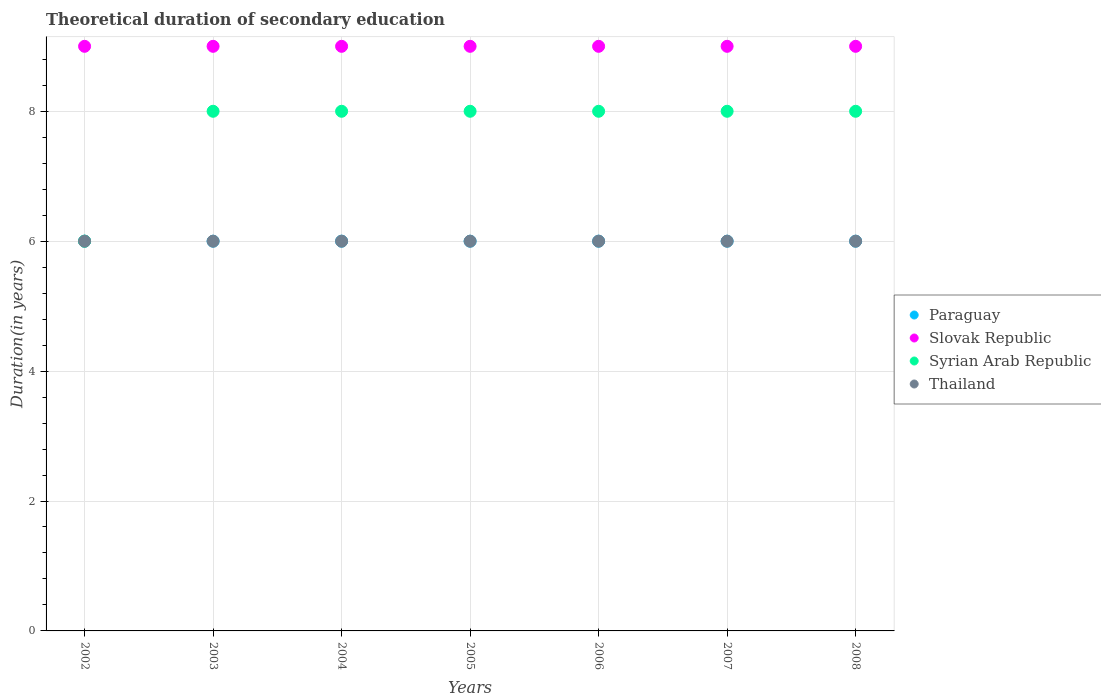Is the number of dotlines equal to the number of legend labels?
Offer a terse response. Yes. What is the total theoretical duration of secondary education in Thailand in 2008?
Offer a very short reply. 6. Across all years, what is the maximum total theoretical duration of secondary education in Syrian Arab Republic?
Ensure brevity in your answer.  8. What is the total total theoretical duration of secondary education in Slovak Republic in the graph?
Ensure brevity in your answer.  63. What is the difference between the total theoretical duration of secondary education in Thailand in 2003 and that in 2008?
Your answer should be compact. 0. What is the difference between the total theoretical duration of secondary education in Thailand in 2003 and the total theoretical duration of secondary education in Syrian Arab Republic in 2007?
Your answer should be very brief. -2. In the year 2005, what is the difference between the total theoretical duration of secondary education in Syrian Arab Republic and total theoretical duration of secondary education in Slovak Republic?
Give a very brief answer. -1. In how many years, is the total theoretical duration of secondary education in Paraguay greater than 5.6 years?
Ensure brevity in your answer.  7. Is the total theoretical duration of secondary education in Syrian Arab Republic in 2004 less than that in 2005?
Your response must be concise. No. Is the difference between the total theoretical duration of secondary education in Syrian Arab Republic in 2004 and 2005 greater than the difference between the total theoretical duration of secondary education in Slovak Republic in 2004 and 2005?
Your answer should be compact. No. What is the difference between the highest and the second highest total theoretical duration of secondary education in Syrian Arab Republic?
Your response must be concise. 0. What is the difference between the highest and the lowest total theoretical duration of secondary education in Syrian Arab Republic?
Keep it short and to the point. 2. Is the sum of the total theoretical duration of secondary education in Thailand in 2006 and 2007 greater than the maximum total theoretical duration of secondary education in Slovak Republic across all years?
Your response must be concise. Yes. Is it the case that in every year, the sum of the total theoretical duration of secondary education in Paraguay and total theoretical duration of secondary education in Slovak Republic  is greater than the sum of total theoretical duration of secondary education in Syrian Arab Republic and total theoretical duration of secondary education in Thailand?
Give a very brief answer. No. Is it the case that in every year, the sum of the total theoretical duration of secondary education in Slovak Republic and total theoretical duration of secondary education in Syrian Arab Republic  is greater than the total theoretical duration of secondary education in Thailand?
Keep it short and to the point. Yes. Is the total theoretical duration of secondary education in Syrian Arab Republic strictly less than the total theoretical duration of secondary education in Slovak Republic over the years?
Give a very brief answer. Yes. How many years are there in the graph?
Make the answer very short. 7. What is the difference between two consecutive major ticks on the Y-axis?
Offer a terse response. 2. Does the graph contain any zero values?
Ensure brevity in your answer.  No. Does the graph contain grids?
Keep it short and to the point. Yes. Where does the legend appear in the graph?
Ensure brevity in your answer.  Center right. How are the legend labels stacked?
Your response must be concise. Vertical. What is the title of the graph?
Your answer should be very brief. Theoretical duration of secondary education. Does "Congo (Republic)" appear as one of the legend labels in the graph?
Offer a very short reply. No. What is the label or title of the X-axis?
Your response must be concise. Years. What is the label or title of the Y-axis?
Make the answer very short. Duration(in years). What is the Duration(in years) in Slovak Republic in 2002?
Your answer should be compact. 9. What is the Duration(in years) in Syrian Arab Republic in 2002?
Provide a short and direct response. 6. What is the Duration(in years) in Thailand in 2002?
Give a very brief answer. 6. What is the Duration(in years) in Paraguay in 2003?
Provide a short and direct response. 6. What is the Duration(in years) of Slovak Republic in 2003?
Your answer should be compact. 9. What is the Duration(in years) in Paraguay in 2004?
Offer a terse response. 6. What is the Duration(in years) of Syrian Arab Republic in 2004?
Provide a succinct answer. 8. What is the Duration(in years) of Paraguay in 2005?
Make the answer very short. 6. What is the Duration(in years) in Paraguay in 2006?
Provide a succinct answer. 6. What is the Duration(in years) of Slovak Republic in 2006?
Your response must be concise. 9. What is the Duration(in years) in Syrian Arab Republic in 2006?
Your answer should be compact. 8. What is the Duration(in years) of Thailand in 2006?
Ensure brevity in your answer.  6. What is the Duration(in years) of Paraguay in 2007?
Your response must be concise. 6. What is the Duration(in years) in Slovak Republic in 2007?
Your answer should be very brief. 9. What is the Duration(in years) in Syrian Arab Republic in 2007?
Offer a very short reply. 8. What is the Duration(in years) in Paraguay in 2008?
Keep it short and to the point. 6. Across all years, what is the maximum Duration(in years) in Paraguay?
Ensure brevity in your answer.  6. Across all years, what is the maximum Duration(in years) in Slovak Republic?
Make the answer very short. 9. Across all years, what is the maximum Duration(in years) of Syrian Arab Republic?
Offer a very short reply. 8. Across all years, what is the minimum Duration(in years) in Paraguay?
Offer a terse response. 6. Across all years, what is the minimum Duration(in years) of Slovak Republic?
Offer a very short reply. 9. Across all years, what is the minimum Duration(in years) in Thailand?
Provide a short and direct response. 6. What is the total Duration(in years) in Paraguay in the graph?
Your answer should be very brief. 42. What is the difference between the Duration(in years) in Syrian Arab Republic in 2002 and that in 2003?
Ensure brevity in your answer.  -2. What is the difference between the Duration(in years) in Paraguay in 2002 and that in 2004?
Your answer should be compact. 0. What is the difference between the Duration(in years) in Syrian Arab Republic in 2002 and that in 2004?
Offer a terse response. -2. What is the difference between the Duration(in years) of Thailand in 2002 and that in 2004?
Offer a very short reply. 0. What is the difference between the Duration(in years) in Paraguay in 2002 and that in 2005?
Provide a short and direct response. 0. What is the difference between the Duration(in years) of Thailand in 2002 and that in 2005?
Give a very brief answer. 0. What is the difference between the Duration(in years) in Paraguay in 2002 and that in 2006?
Offer a terse response. 0. What is the difference between the Duration(in years) of Slovak Republic in 2002 and that in 2006?
Make the answer very short. 0. What is the difference between the Duration(in years) in Paraguay in 2002 and that in 2007?
Provide a short and direct response. 0. What is the difference between the Duration(in years) in Thailand in 2002 and that in 2007?
Your answer should be compact. 0. What is the difference between the Duration(in years) in Paraguay in 2002 and that in 2008?
Your answer should be very brief. 0. What is the difference between the Duration(in years) in Slovak Republic in 2002 and that in 2008?
Your answer should be very brief. 0. What is the difference between the Duration(in years) in Syrian Arab Republic in 2002 and that in 2008?
Give a very brief answer. -2. What is the difference between the Duration(in years) of Thailand in 2002 and that in 2008?
Keep it short and to the point. 0. What is the difference between the Duration(in years) of Thailand in 2003 and that in 2004?
Offer a very short reply. 0. What is the difference between the Duration(in years) of Paraguay in 2003 and that in 2005?
Keep it short and to the point. 0. What is the difference between the Duration(in years) of Slovak Republic in 2003 and that in 2005?
Offer a terse response. 0. What is the difference between the Duration(in years) in Syrian Arab Republic in 2003 and that in 2006?
Give a very brief answer. 0. What is the difference between the Duration(in years) in Thailand in 2003 and that in 2006?
Your answer should be very brief. 0. What is the difference between the Duration(in years) of Syrian Arab Republic in 2003 and that in 2007?
Your answer should be compact. 0. What is the difference between the Duration(in years) of Thailand in 2003 and that in 2008?
Your response must be concise. 0. What is the difference between the Duration(in years) in Paraguay in 2004 and that in 2005?
Provide a succinct answer. 0. What is the difference between the Duration(in years) of Syrian Arab Republic in 2004 and that in 2005?
Give a very brief answer. 0. What is the difference between the Duration(in years) of Paraguay in 2004 and that in 2006?
Offer a very short reply. 0. What is the difference between the Duration(in years) in Slovak Republic in 2004 and that in 2006?
Provide a short and direct response. 0. What is the difference between the Duration(in years) in Paraguay in 2004 and that in 2007?
Offer a terse response. 0. What is the difference between the Duration(in years) in Slovak Republic in 2004 and that in 2007?
Your response must be concise. 0. What is the difference between the Duration(in years) of Paraguay in 2004 and that in 2008?
Provide a succinct answer. 0. What is the difference between the Duration(in years) in Thailand in 2004 and that in 2008?
Make the answer very short. 0. What is the difference between the Duration(in years) of Slovak Republic in 2005 and that in 2006?
Your answer should be very brief. 0. What is the difference between the Duration(in years) of Thailand in 2005 and that in 2006?
Provide a succinct answer. 0. What is the difference between the Duration(in years) in Paraguay in 2005 and that in 2007?
Give a very brief answer. 0. What is the difference between the Duration(in years) of Syrian Arab Republic in 2005 and that in 2007?
Provide a succinct answer. 0. What is the difference between the Duration(in years) of Thailand in 2005 and that in 2007?
Provide a short and direct response. 0. What is the difference between the Duration(in years) of Syrian Arab Republic in 2006 and that in 2007?
Provide a succinct answer. 0. What is the difference between the Duration(in years) of Thailand in 2006 and that in 2007?
Offer a very short reply. 0. What is the difference between the Duration(in years) of Paraguay in 2006 and that in 2008?
Provide a short and direct response. 0. What is the difference between the Duration(in years) in Paraguay in 2007 and that in 2008?
Keep it short and to the point. 0. What is the difference between the Duration(in years) in Thailand in 2007 and that in 2008?
Ensure brevity in your answer.  0. What is the difference between the Duration(in years) in Paraguay in 2002 and the Duration(in years) in Slovak Republic in 2003?
Ensure brevity in your answer.  -3. What is the difference between the Duration(in years) of Paraguay in 2002 and the Duration(in years) of Thailand in 2003?
Provide a succinct answer. 0. What is the difference between the Duration(in years) in Slovak Republic in 2002 and the Duration(in years) in Thailand in 2003?
Provide a succinct answer. 3. What is the difference between the Duration(in years) in Paraguay in 2002 and the Duration(in years) in Syrian Arab Republic in 2004?
Your answer should be compact. -2. What is the difference between the Duration(in years) in Slovak Republic in 2002 and the Duration(in years) in Thailand in 2004?
Provide a succinct answer. 3. What is the difference between the Duration(in years) in Syrian Arab Republic in 2002 and the Duration(in years) in Thailand in 2004?
Make the answer very short. 0. What is the difference between the Duration(in years) in Slovak Republic in 2002 and the Duration(in years) in Thailand in 2005?
Make the answer very short. 3. What is the difference between the Duration(in years) in Syrian Arab Republic in 2002 and the Duration(in years) in Thailand in 2005?
Provide a succinct answer. 0. What is the difference between the Duration(in years) of Paraguay in 2002 and the Duration(in years) of Syrian Arab Republic in 2006?
Make the answer very short. -2. What is the difference between the Duration(in years) in Paraguay in 2002 and the Duration(in years) in Slovak Republic in 2007?
Provide a short and direct response. -3. What is the difference between the Duration(in years) in Slovak Republic in 2002 and the Duration(in years) in Syrian Arab Republic in 2007?
Ensure brevity in your answer.  1. What is the difference between the Duration(in years) of Syrian Arab Republic in 2002 and the Duration(in years) of Thailand in 2007?
Offer a terse response. 0. What is the difference between the Duration(in years) of Paraguay in 2002 and the Duration(in years) of Thailand in 2008?
Offer a terse response. 0. What is the difference between the Duration(in years) in Paraguay in 2003 and the Duration(in years) in Slovak Republic in 2004?
Offer a terse response. -3. What is the difference between the Duration(in years) in Slovak Republic in 2003 and the Duration(in years) in Thailand in 2004?
Keep it short and to the point. 3. What is the difference between the Duration(in years) in Syrian Arab Republic in 2003 and the Duration(in years) in Thailand in 2004?
Provide a short and direct response. 2. What is the difference between the Duration(in years) in Paraguay in 2003 and the Duration(in years) in Syrian Arab Republic in 2005?
Provide a short and direct response. -2. What is the difference between the Duration(in years) of Paraguay in 2003 and the Duration(in years) of Syrian Arab Republic in 2006?
Give a very brief answer. -2. What is the difference between the Duration(in years) in Slovak Republic in 2003 and the Duration(in years) in Thailand in 2006?
Provide a succinct answer. 3. What is the difference between the Duration(in years) in Syrian Arab Republic in 2003 and the Duration(in years) in Thailand in 2006?
Offer a terse response. 2. What is the difference between the Duration(in years) in Paraguay in 2003 and the Duration(in years) in Slovak Republic in 2007?
Your answer should be compact. -3. What is the difference between the Duration(in years) in Paraguay in 2003 and the Duration(in years) in Syrian Arab Republic in 2007?
Keep it short and to the point. -2. What is the difference between the Duration(in years) in Paraguay in 2003 and the Duration(in years) in Thailand in 2007?
Ensure brevity in your answer.  0. What is the difference between the Duration(in years) of Paraguay in 2003 and the Duration(in years) of Syrian Arab Republic in 2008?
Your response must be concise. -2. What is the difference between the Duration(in years) in Slovak Republic in 2003 and the Duration(in years) in Syrian Arab Republic in 2008?
Give a very brief answer. 1. What is the difference between the Duration(in years) in Paraguay in 2004 and the Duration(in years) in Slovak Republic in 2005?
Your response must be concise. -3. What is the difference between the Duration(in years) of Paraguay in 2004 and the Duration(in years) of Syrian Arab Republic in 2005?
Ensure brevity in your answer.  -2. What is the difference between the Duration(in years) of Paraguay in 2004 and the Duration(in years) of Thailand in 2005?
Provide a succinct answer. 0. What is the difference between the Duration(in years) of Slovak Republic in 2004 and the Duration(in years) of Thailand in 2005?
Provide a succinct answer. 3. What is the difference between the Duration(in years) of Syrian Arab Republic in 2004 and the Duration(in years) of Thailand in 2005?
Provide a succinct answer. 2. What is the difference between the Duration(in years) of Paraguay in 2004 and the Duration(in years) of Slovak Republic in 2006?
Your response must be concise. -3. What is the difference between the Duration(in years) in Paraguay in 2004 and the Duration(in years) in Thailand in 2006?
Provide a short and direct response. 0. What is the difference between the Duration(in years) in Slovak Republic in 2004 and the Duration(in years) in Syrian Arab Republic in 2006?
Ensure brevity in your answer.  1. What is the difference between the Duration(in years) of Syrian Arab Republic in 2004 and the Duration(in years) of Thailand in 2006?
Offer a terse response. 2. What is the difference between the Duration(in years) of Paraguay in 2004 and the Duration(in years) of Slovak Republic in 2007?
Keep it short and to the point. -3. What is the difference between the Duration(in years) of Paraguay in 2004 and the Duration(in years) of Syrian Arab Republic in 2007?
Give a very brief answer. -2. What is the difference between the Duration(in years) of Paraguay in 2004 and the Duration(in years) of Thailand in 2007?
Your response must be concise. 0. What is the difference between the Duration(in years) of Slovak Republic in 2004 and the Duration(in years) of Syrian Arab Republic in 2007?
Your answer should be compact. 1. What is the difference between the Duration(in years) of Slovak Republic in 2004 and the Duration(in years) of Thailand in 2008?
Your response must be concise. 3. What is the difference between the Duration(in years) of Syrian Arab Republic in 2004 and the Duration(in years) of Thailand in 2008?
Provide a succinct answer. 2. What is the difference between the Duration(in years) of Paraguay in 2005 and the Duration(in years) of Thailand in 2006?
Offer a very short reply. 0. What is the difference between the Duration(in years) of Slovak Republic in 2005 and the Duration(in years) of Syrian Arab Republic in 2006?
Ensure brevity in your answer.  1. What is the difference between the Duration(in years) in Paraguay in 2005 and the Duration(in years) in Slovak Republic in 2007?
Give a very brief answer. -3. What is the difference between the Duration(in years) of Paraguay in 2005 and the Duration(in years) of Syrian Arab Republic in 2007?
Ensure brevity in your answer.  -2. What is the difference between the Duration(in years) in Slovak Republic in 2005 and the Duration(in years) in Syrian Arab Republic in 2007?
Your answer should be compact. 1. What is the difference between the Duration(in years) of Syrian Arab Republic in 2005 and the Duration(in years) of Thailand in 2007?
Ensure brevity in your answer.  2. What is the difference between the Duration(in years) of Paraguay in 2005 and the Duration(in years) of Syrian Arab Republic in 2008?
Provide a short and direct response. -2. What is the difference between the Duration(in years) of Paraguay in 2005 and the Duration(in years) of Thailand in 2008?
Your answer should be very brief. 0. What is the difference between the Duration(in years) in Slovak Republic in 2005 and the Duration(in years) in Syrian Arab Republic in 2008?
Offer a very short reply. 1. What is the difference between the Duration(in years) in Slovak Republic in 2005 and the Duration(in years) in Thailand in 2008?
Offer a terse response. 3. What is the difference between the Duration(in years) in Syrian Arab Republic in 2005 and the Duration(in years) in Thailand in 2008?
Keep it short and to the point. 2. What is the difference between the Duration(in years) in Paraguay in 2006 and the Duration(in years) in Slovak Republic in 2007?
Give a very brief answer. -3. What is the difference between the Duration(in years) in Paraguay in 2006 and the Duration(in years) in Syrian Arab Republic in 2007?
Provide a succinct answer. -2. What is the difference between the Duration(in years) of Slovak Republic in 2006 and the Duration(in years) of Syrian Arab Republic in 2007?
Offer a terse response. 1. What is the difference between the Duration(in years) in Slovak Republic in 2006 and the Duration(in years) in Thailand in 2007?
Your response must be concise. 3. What is the difference between the Duration(in years) of Paraguay in 2006 and the Duration(in years) of Syrian Arab Republic in 2008?
Your answer should be very brief. -2. What is the difference between the Duration(in years) of Paraguay in 2006 and the Duration(in years) of Thailand in 2008?
Offer a very short reply. 0. What is the difference between the Duration(in years) in Slovak Republic in 2006 and the Duration(in years) in Thailand in 2008?
Offer a very short reply. 3. What is the difference between the Duration(in years) in Syrian Arab Republic in 2006 and the Duration(in years) in Thailand in 2008?
Give a very brief answer. 2. What is the average Duration(in years) in Paraguay per year?
Provide a succinct answer. 6. What is the average Duration(in years) in Slovak Republic per year?
Give a very brief answer. 9. What is the average Duration(in years) in Syrian Arab Republic per year?
Your answer should be very brief. 7.71. In the year 2002, what is the difference between the Duration(in years) in Paraguay and Duration(in years) in Syrian Arab Republic?
Offer a terse response. 0. In the year 2002, what is the difference between the Duration(in years) in Slovak Republic and Duration(in years) in Syrian Arab Republic?
Offer a terse response. 3. In the year 2003, what is the difference between the Duration(in years) in Paraguay and Duration(in years) in Thailand?
Offer a terse response. 0. In the year 2003, what is the difference between the Duration(in years) in Slovak Republic and Duration(in years) in Syrian Arab Republic?
Your answer should be compact. 1. In the year 2004, what is the difference between the Duration(in years) of Paraguay and Duration(in years) of Thailand?
Your response must be concise. 0. In the year 2004, what is the difference between the Duration(in years) of Slovak Republic and Duration(in years) of Thailand?
Offer a terse response. 3. In the year 2005, what is the difference between the Duration(in years) in Paraguay and Duration(in years) in Thailand?
Provide a short and direct response. 0. In the year 2005, what is the difference between the Duration(in years) in Slovak Republic and Duration(in years) in Thailand?
Offer a very short reply. 3. In the year 2005, what is the difference between the Duration(in years) in Syrian Arab Republic and Duration(in years) in Thailand?
Provide a succinct answer. 2. In the year 2006, what is the difference between the Duration(in years) in Paraguay and Duration(in years) in Slovak Republic?
Give a very brief answer. -3. In the year 2006, what is the difference between the Duration(in years) in Paraguay and Duration(in years) in Syrian Arab Republic?
Ensure brevity in your answer.  -2. In the year 2006, what is the difference between the Duration(in years) in Paraguay and Duration(in years) in Thailand?
Make the answer very short. 0. In the year 2006, what is the difference between the Duration(in years) in Slovak Republic and Duration(in years) in Syrian Arab Republic?
Your answer should be very brief. 1. In the year 2007, what is the difference between the Duration(in years) in Paraguay and Duration(in years) in Thailand?
Your response must be concise. 0. In the year 2007, what is the difference between the Duration(in years) in Slovak Republic and Duration(in years) in Thailand?
Your answer should be very brief. 3. In the year 2008, what is the difference between the Duration(in years) in Paraguay and Duration(in years) in Slovak Republic?
Make the answer very short. -3. In the year 2008, what is the difference between the Duration(in years) of Paraguay and Duration(in years) of Syrian Arab Republic?
Your response must be concise. -2. In the year 2008, what is the difference between the Duration(in years) of Slovak Republic and Duration(in years) of Syrian Arab Republic?
Your answer should be compact. 1. In the year 2008, what is the difference between the Duration(in years) in Syrian Arab Republic and Duration(in years) in Thailand?
Make the answer very short. 2. What is the ratio of the Duration(in years) in Paraguay in 2002 to that in 2003?
Offer a terse response. 1. What is the ratio of the Duration(in years) of Syrian Arab Republic in 2002 to that in 2003?
Offer a very short reply. 0.75. What is the ratio of the Duration(in years) in Slovak Republic in 2002 to that in 2004?
Your response must be concise. 1. What is the ratio of the Duration(in years) in Thailand in 2002 to that in 2004?
Make the answer very short. 1. What is the ratio of the Duration(in years) of Slovak Republic in 2002 to that in 2005?
Keep it short and to the point. 1. What is the ratio of the Duration(in years) of Syrian Arab Republic in 2002 to that in 2006?
Your answer should be compact. 0.75. What is the ratio of the Duration(in years) in Thailand in 2002 to that in 2006?
Provide a succinct answer. 1. What is the ratio of the Duration(in years) in Slovak Republic in 2002 to that in 2007?
Your answer should be compact. 1. What is the ratio of the Duration(in years) in Syrian Arab Republic in 2002 to that in 2007?
Ensure brevity in your answer.  0.75. What is the ratio of the Duration(in years) in Thailand in 2002 to that in 2007?
Ensure brevity in your answer.  1. What is the ratio of the Duration(in years) in Paraguay in 2002 to that in 2008?
Ensure brevity in your answer.  1. What is the ratio of the Duration(in years) in Thailand in 2002 to that in 2008?
Provide a short and direct response. 1. What is the ratio of the Duration(in years) in Paraguay in 2003 to that in 2004?
Give a very brief answer. 1. What is the ratio of the Duration(in years) in Thailand in 2003 to that in 2005?
Your response must be concise. 1. What is the ratio of the Duration(in years) in Slovak Republic in 2003 to that in 2006?
Your answer should be compact. 1. What is the ratio of the Duration(in years) in Thailand in 2003 to that in 2006?
Ensure brevity in your answer.  1. What is the ratio of the Duration(in years) of Slovak Republic in 2003 to that in 2007?
Your answer should be compact. 1. What is the ratio of the Duration(in years) in Syrian Arab Republic in 2003 to that in 2007?
Provide a succinct answer. 1. What is the ratio of the Duration(in years) of Paraguay in 2003 to that in 2008?
Offer a terse response. 1. What is the ratio of the Duration(in years) in Slovak Republic in 2003 to that in 2008?
Keep it short and to the point. 1. What is the ratio of the Duration(in years) of Syrian Arab Republic in 2003 to that in 2008?
Your answer should be compact. 1. What is the ratio of the Duration(in years) of Thailand in 2003 to that in 2008?
Offer a very short reply. 1. What is the ratio of the Duration(in years) of Paraguay in 2004 to that in 2005?
Make the answer very short. 1. What is the ratio of the Duration(in years) in Thailand in 2004 to that in 2005?
Your answer should be compact. 1. What is the ratio of the Duration(in years) of Slovak Republic in 2004 to that in 2006?
Offer a terse response. 1. What is the ratio of the Duration(in years) in Syrian Arab Republic in 2004 to that in 2006?
Keep it short and to the point. 1. What is the ratio of the Duration(in years) in Thailand in 2004 to that in 2006?
Offer a very short reply. 1. What is the ratio of the Duration(in years) of Syrian Arab Republic in 2004 to that in 2007?
Provide a short and direct response. 1. What is the ratio of the Duration(in years) in Thailand in 2004 to that in 2007?
Offer a terse response. 1. What is the ratio of the Duration(in years) in Paraguay in 2004 to that in 2008?
Provide a succinct answer. 1. What is the ratio of the Duration(in years) of Paraguay in 2005 to that in 2006?
Make the answer very short. 1. What is the ratio of the Duration(in years) of Syrian Arab Republic in 2005 to that in 2006?
Your answer should be very brief. 1. What is the ratio of the Duration(in years) of Slovak Republic in 2005 to that in 2007?
Give a very brief answer. 1. What is the ratio of the Duration(in years) in Syrian Arab Republic in 2005 to that in 2007?
Your answer should be compact. 1. What is the ratio of the Duration(in years) of Thailand in 2005 to that in 2007?
Your answer should be very brief. 1. What is the ratio of the Duration(in years) in Paraguay in 2005 to that in 2008?
Your response must be concise. 1. What is the ratio of the Duration(in years) of Thailand in 2005 to that in 2008?
Give a very brief answer. 1. What is the ratio of the Duration(in years) in Syrian Arab Republic in 2006 to that in 2007?
Your answer should be very brief. 1. What is the ratio of the Duration(in years) in Thailand in 2006 to that in 2007?
Make the answer very short. 1. What is the ratio of the Duration(in years) of Syrian Arab Republic in 2006 to that in 2008?
Your answer should be very brief. 1. What is the ratio of the Duration(in years) in Thailand in 2006 to that in 2008?
Your answer should be compact. 1. What is the ratio of the Duration(in years) in Thailand in 2007 to that in 2008?
Keep it short and to the point. 1. What is the difference between the highest and the second highest Duration(in years) of Paraguay?
Keep it short and to the point. 0. What is the difference between the highest and the second highest Duration(in years) in Slovak Republic?
Provide a short and direct response. 0. What is the difference between the highest and the second highest Duration(in years) of Thailand?
Your answer should be very brief. 0. What is the difference between the highest and the lowest Duration(in years) of Paraguay?
Give a very brief answer. 0. What is the difference between the highest and the lowest Duration(in years) of Syrian Arab Republic?
Your answer should be very brief. 2. What is the difference between the highest and the lowest Duration(in years) of Thailand?
Make the answer very short. 0. 